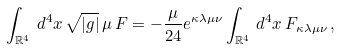Convert formula to latex. <formula><loc_0><loc_0><loc_500><loc_500>\int _ { \mathbb { R } ^ { 4 } } \, d ^ { 4 } x \, \sqrt { | g | } \, \mu \, F = - \frac { \mu } { 2 4 } e ^ { \kappa \lambda \mu \nu } \int _ { \mathbb { R } ^ { 4 } } \, d ^ { 4 } x \, F _ { \kappa \lambda \mu \nu } \, ,</formula> 